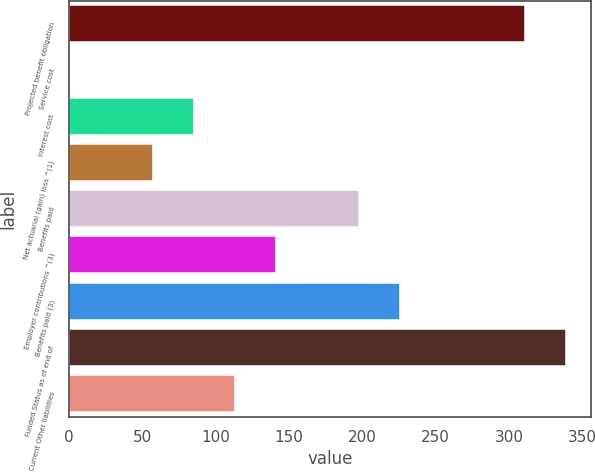Convert chart. <chart><loc_0><loc_0><loc_500><loc_500><bar_chart><fcel>Projected benefit obligation<fcel>Service cost<fcel>Interest cost<fcel>Net actuarial (gain) loss ^(1)<fcel>Benefits paid<fcel>Employer contributions ^(3)<fcel>Benefits paid (3)<fcel>Funded Status as of end of<fcel>Current Other liabilities<nl><fcel>311.2<fcel>1<fcel>85.3<fcel>57.2<fcel>197.7<fcel>141.5<fcel>225.8<fcel>339.3<fcel>113.4<nl></chart> 